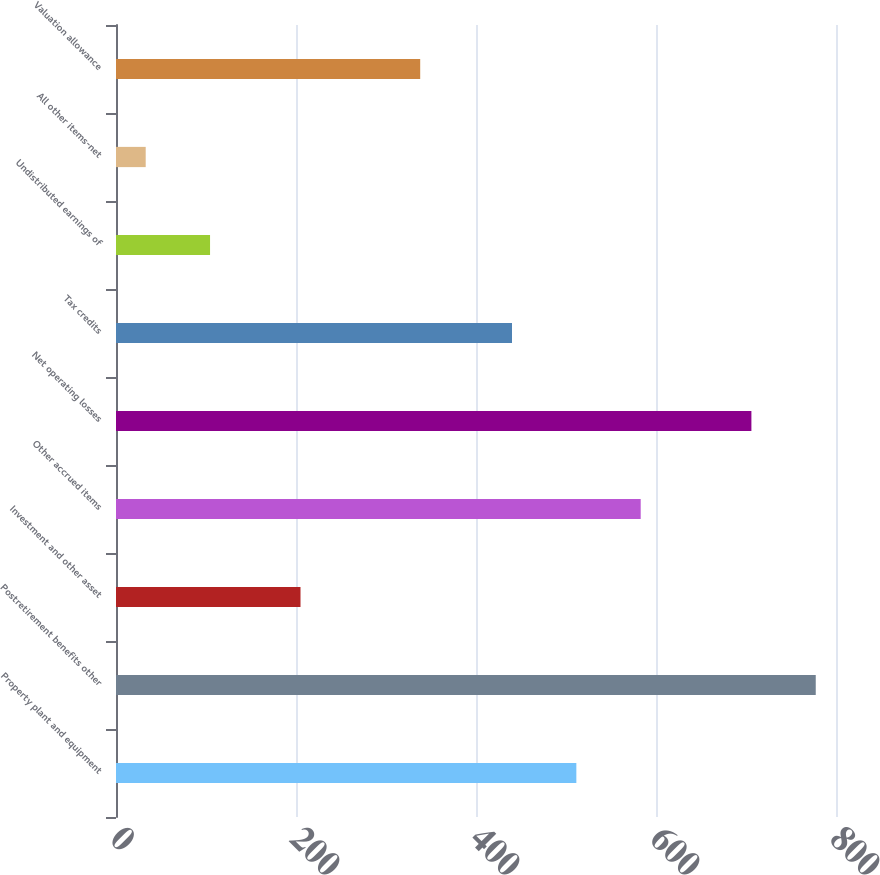Convert chart. <chart><loc_0><loc_0><loc_500><loc_500><bar_chart><fcel>Property plant and equipment<fcel>Postretirement benefits other<fcel>Investment and other asset<fcel>Other accrued items<fcel>Net operating losses<fcel>Tax credits<fcel>Undistributed earnings of<fcel>All other items-net<fcel>Valuation allowance<nl><fcel>511.5<fcel>777.5<fcel>205<fcel>583<fcel>706<fcel>440<fcel>104.5<fcel>33<fcel>338<nl></chart> 